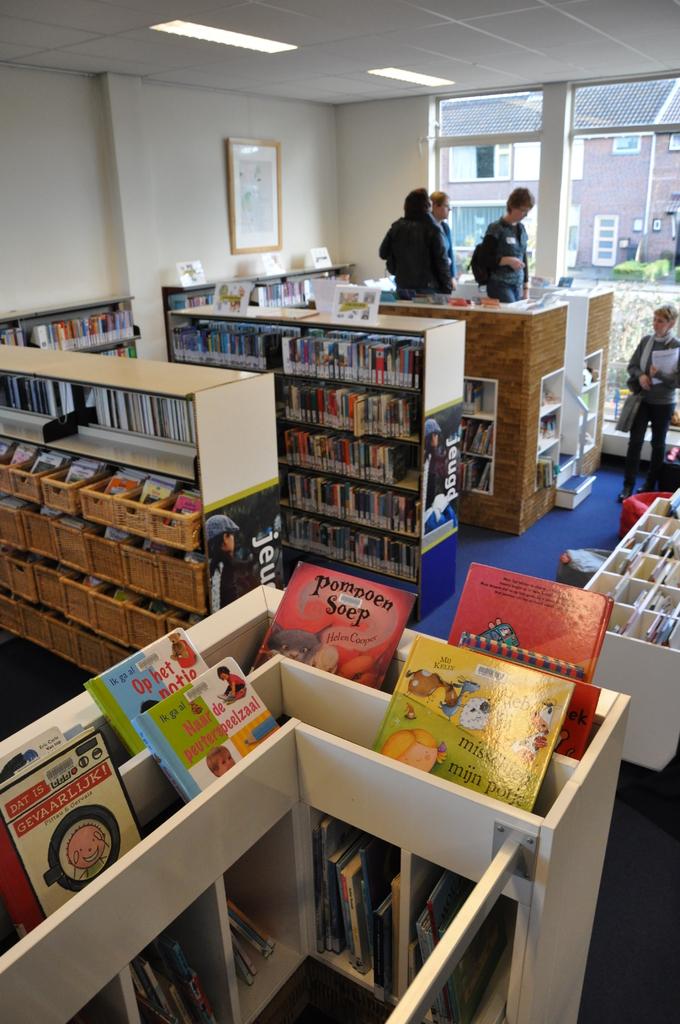What is the title of the red book on the left?
Your answer should be compact. Pompoen soep. 